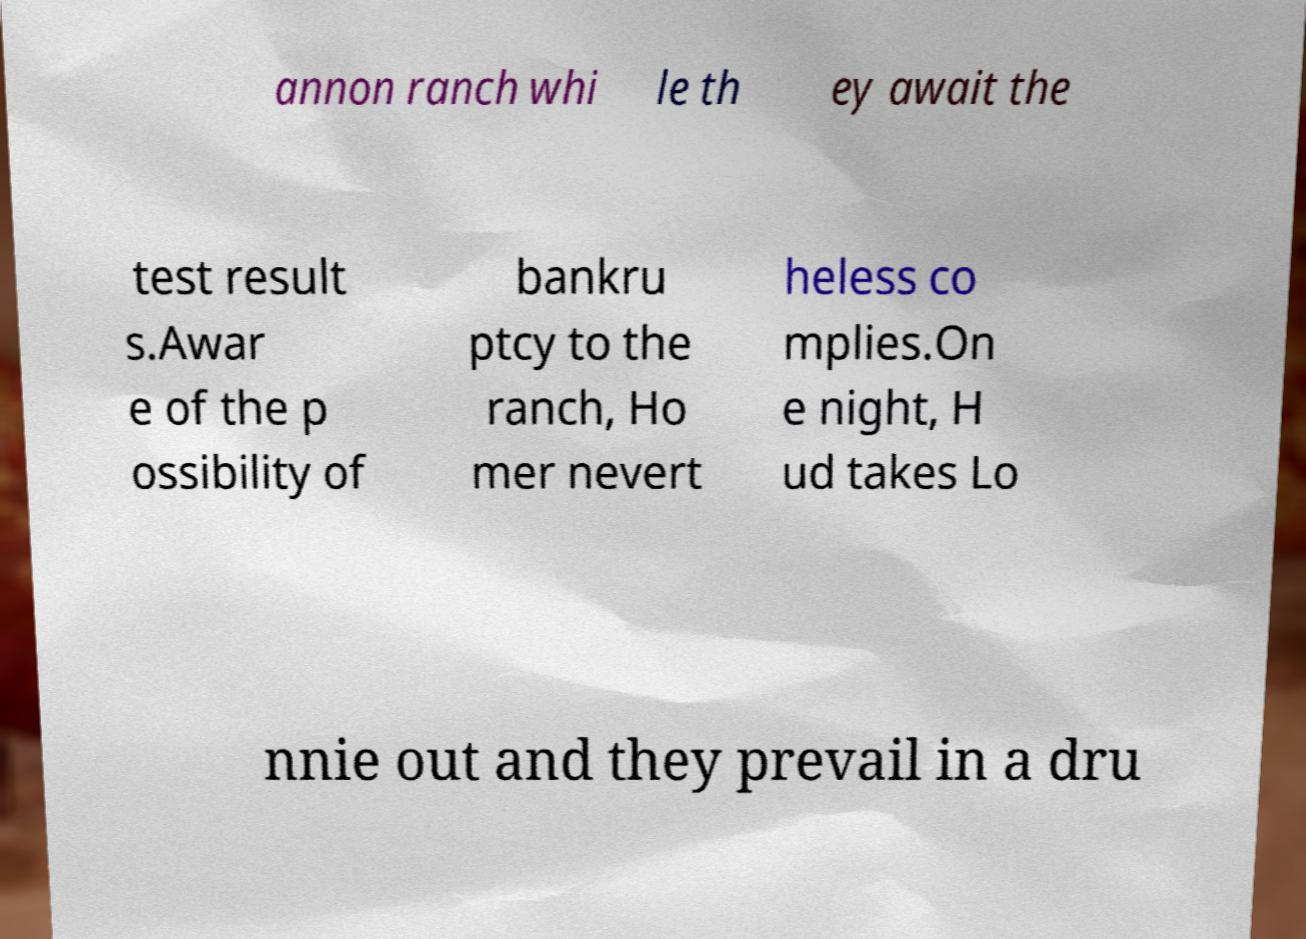Please identify and transcribe the text found in this image. annon ranch whi le th ey await the test result s.Awar e of the p ossibility of bankru ptcy to the ranch, Ho mer nevert heless co mplies.On e night, H ud takes Lo nnie out and they prevail in a dru 